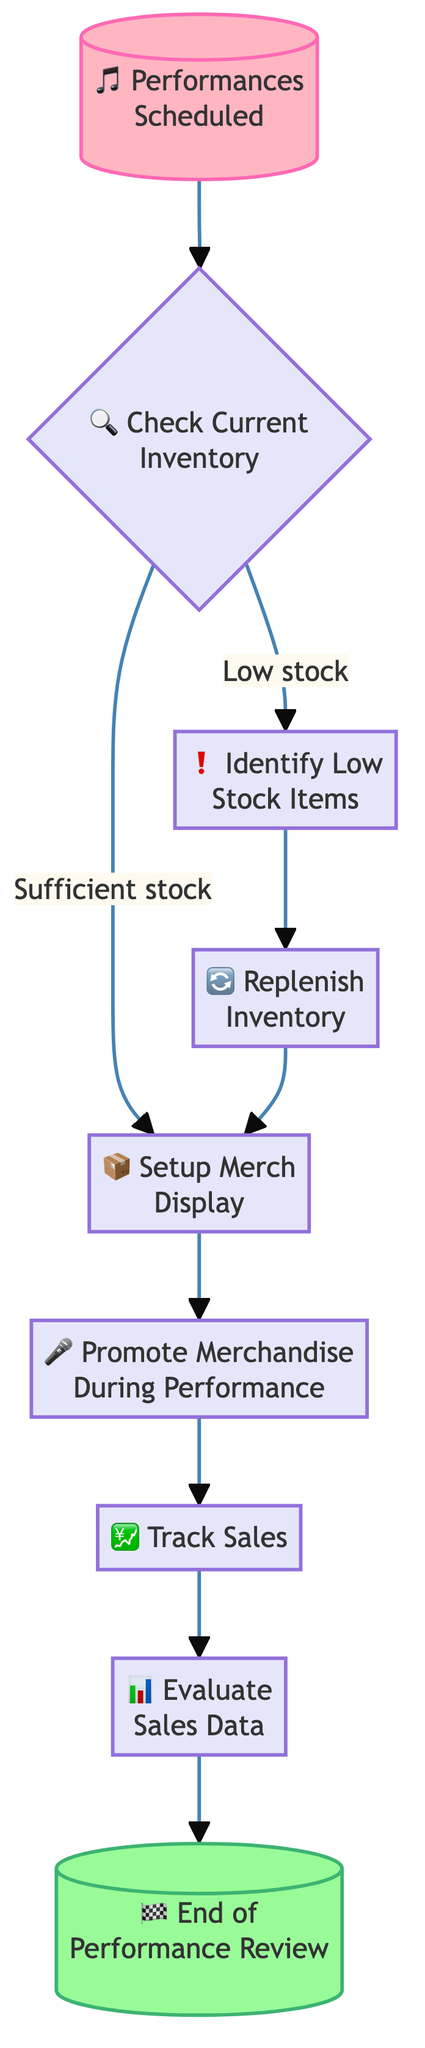What is the first step in the flowchart? The first step is labeled "Performances Scheduled," indicating that it is the starting point for managing inventory during performances.
Answer: Performances Scheduled How many decision nodes are present in the flowchart? There is one decision node, which is "Identify Low Stock Items," where a determination is made about stock levels.
Answer: 1 What happens if the inventory check indicates sufficient stock? If the inventory check indicates sufficient stock, the flow proceeds to "Setup Merch Display" directly, indicating that no replenishment is required.
Answer: Setup Merch Display After replenishing inventory, what is the next process? The next process after replenishing inventory is "Setup Merch Display," indicating merchandise is organized for visibility post-replenishment.
Answer: Setup Merch Display Which process occurs directly after promoting merchandise during the performance? The process that follows promoting merchandise during the performance is "Track Sales," which deals with recording merchandise sold during the event.
Answer: Track Sales What is the final step in the flowchart? The final step is "End of Performance Review," concluding the process and incorporating any updates made during the performance.
Answer: End of Performance Review If the current inventory is low, which process is taken? If the current inventory is low, the process taken is "Replenish Inventory," where items that are low are reordered or restocked.
Answer: Replenish Inventory What process follows after evaluating sales data? After evaluating sales data, the flowchart proceeds to the "End of Performance Review," indicating the conclusion of the performance management cycle.
Answer: End of Performance Review 